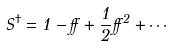Convert formula to latex. <formula><loc_0><loc_0><loc_500><loc_500>S ^ { \dagger } = 1 - \alpha + \frac { 1 } { 2 } \alpha ^ { 2 } + \cdots</formula> 